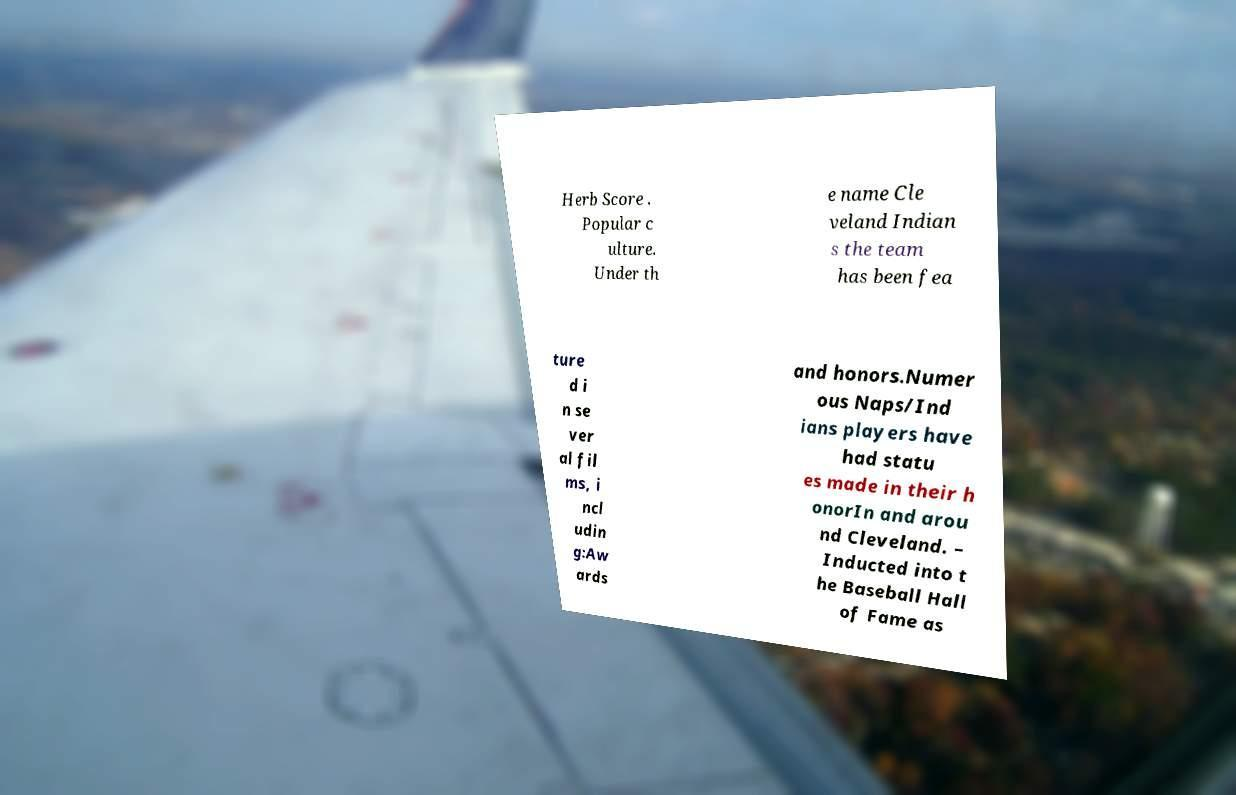Could you extract and type out the text from this image? Herb Score . Popular c ulture. Under th e name Cle veland Indian s the team has been fea ture d i n se ver al fil ms, i ncl udin g:Aw ards and honors.Numer ous Naps/Ind ians players have had statu es made in their h onorIn and arou nd Cleveland. – Inducted into t he Baseball Hall of Fame as 